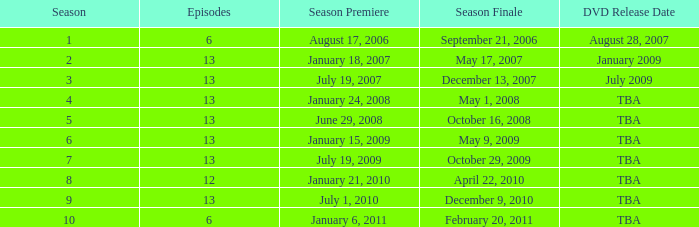Which season had fewer than 13 episodes and aired its season finale on February 20, 2011? 1.0. 